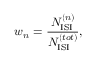<formula> <loc_0><loc_0><loc_500><loc_500>w _ { n } = \frac { N _ { I S I } ^ { ( n ) } } { N _ { I S I } ^ { ( t o t ) } } ,</formula> 